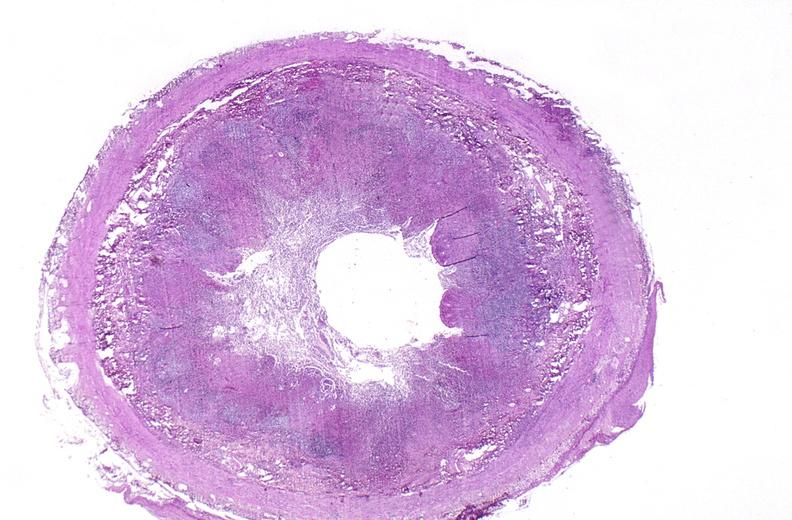does atrophy secondary to pituitectomy show appendix, acute appendicitis?
Answer the question using a single word or phrase. No 